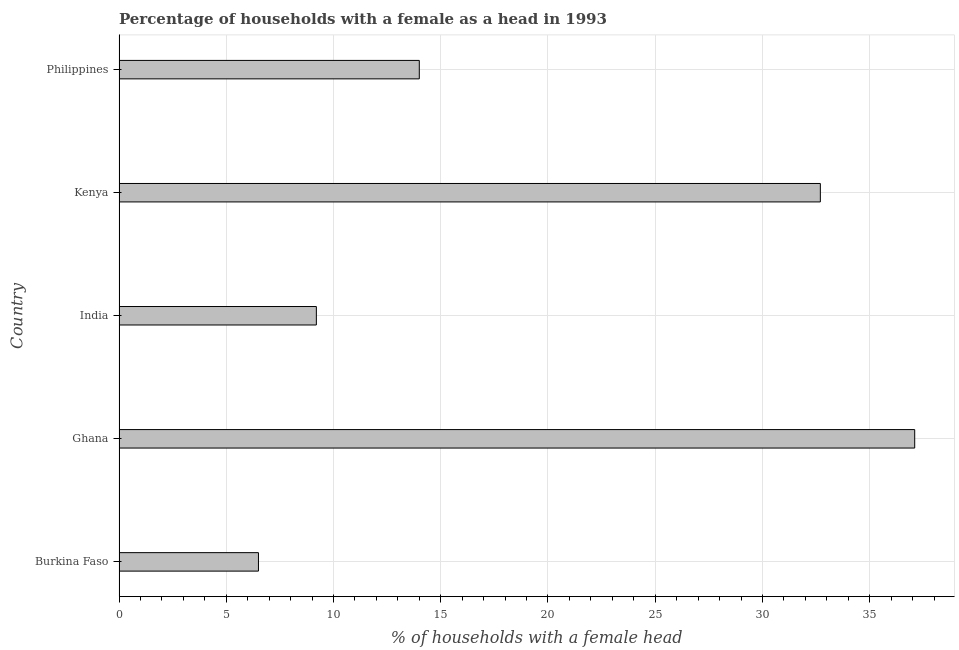What is the title of the graph?
Ensure brevity in your answer.  Percentage of households with a female as a head in 1993. What is the label or title of the X-axis?
Keep it short and to the point. % of households with a female head. What is the number of female supervised households in Ghana?
Offer a terse response. 37.1. Across all countries, what is the maximum number of female supervised households?
Keep it short and to the point. 37.1. In which country was the number of female supervised households minimum?
Offer a very short reply. Burkina Faso. What is the sum of the number of female supervised households?
Ensure brevity in your answer.  99.5. What is the difference between the number of female supervised households in India and Philippines?
Give a very brief answer. -4.8. In how many countries, is the number of female supervised households greater than 7 %?
Ensure brevity in your answer.  4. What is the ratio of the number of female supervised households in Burkina Faso to that in India?
Ensure brevity in your answer.  0.71. Is the number of female supervised households in Burkina Faso less than that in Philippines?
Keep it short and to the point. Yes. Is the difference between the number of female supervised households in India and Philippines greater than the difference between any two countries?
Your response must be concise. No. What is the difference between the highest and the second highest number of female supervised households?
Ensure brevity in your answer.  4.4. What is the difference between the highest and the lowest number of female supervised households?
Give a very brief answer. 30.6. In how many countries, is the number of female supervised households greater than the average number of female supervised households taken over all countries?
Make the answer very short. 2. How many bars are there?
Give a very brief answer. 5. How many countries are there in the graph?
Your response must be concise. 5. What is the % of households with a female head of Ghana?
Your answer should be compact. 37.1. What is the % of households with a female head of India?
Provide a short and direct response. 9.2. What is the % of households with a female head in Kenya?
Your response must be concise. 32.7. What is the difference between the % of households with a female head in Burkina Faso and Ghana?
Offer a terse response. -30.6. What is the difference between the % of households with a female head in Burkina Faso and Kenya?
Provide a short and direct response. -26.2. What is the difference between the % of households with a female head in Burkina Faso and Philippines?
Offer a very short reply. -7.5. What is the difference between the % of households with a female head in Ghana and India?
Your answer should be very brief. 27.9. What is the difference between the % of households with a female head in Ghana and Philippines?
Keep it short and to the point. 23.1. What is the difference between the % of households with a female head in India and Kenya?
Keep it short and to the point. -23.5. What is the difference between the % of households with a female head in India and Philippines?
Ensure brevity in your answer.  -4.8. What is the difference between the % of households with a female head in Kenya and Philippines?
Your response must be concise. 18.7. What is the ratio of the % of households with a female head in Burkina Faso to that in Ghana?
Your answer should be compact. 0.17. What is the ratio of the % of households with a female head in Burkina Faso to that in India?
Make the answer very short. 0.71. What is the ratio of the % of households with a female head in Burkina Faso to that in Kenya?
Provide a short and direct response. 0.2. What is the ratio of the % of households with a female head in Burkina Faso to that in Philippines?
Ensure brevity in your answer.  0.46. What is the ratio of the % of households with a female head in Ghana to that in India?
Offer a very short reply. 4.03. What is the ratio of the % of households with a female head in Ghana to that in Kenya?
Offer a terse response. 1.14. What is the ratio of the % of households with a female head in Ghana to that in Philippines?
Give a very brief answer. 2.65. What is the ratio of the % of households with a female head in India to that in Kenya?
Ensure brevity in your answer.  0.28. What is the ratio of the % of households with a female head in India to that in Philippines?
Give a very brief answer. 0.66. What is the ratio of the % of households with a female head in Kenya to that in Philippines?
Give a very brief answer. 2.34. 